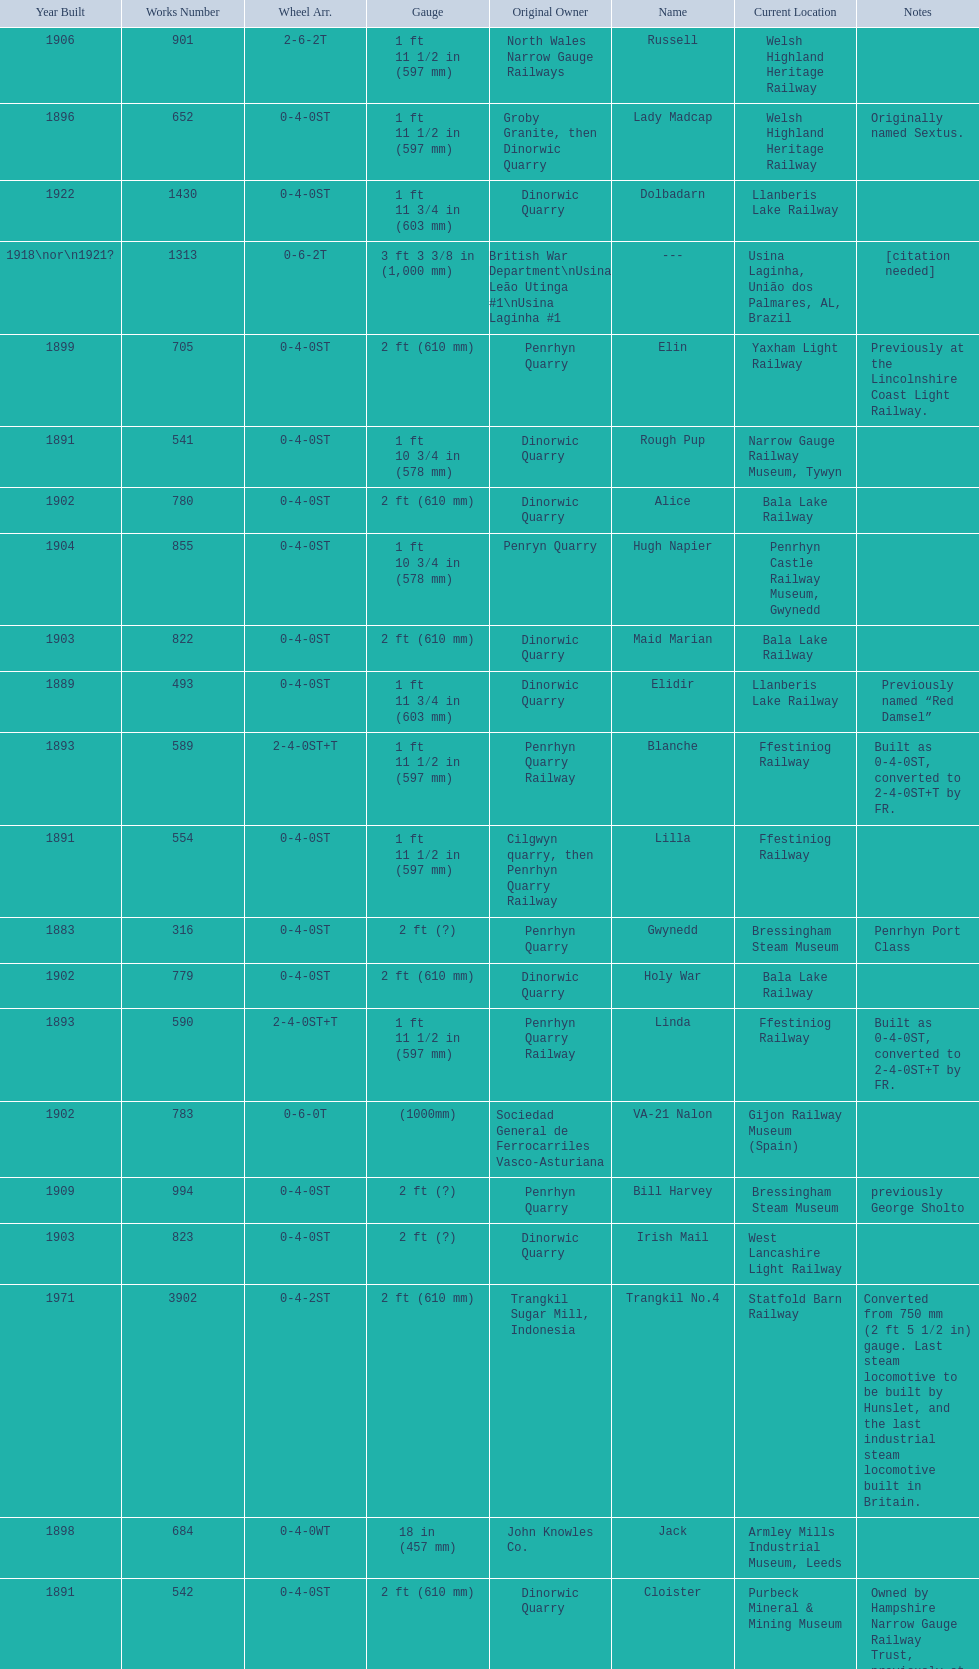How many steam locomotives are currently located at the bala lake railway? 364. 